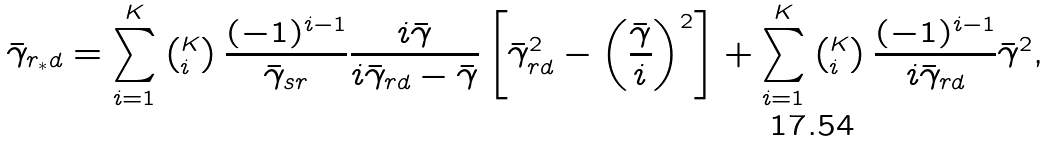<formula> <loc_0><loc_0><loc_500><loc_500>\bar { \gamma } _ { r _ { * } d } = \sum _ { i = 1 } ^ { K } \left ( _ { i } ^ { K } \right ) \frac { ( - 1 ) ^ { i - 1 } } { \bar { \gamma } _ { s r } } \frac { i \bar { \gamma } } { i \bar { \gamma } _ { r d } - \bar { \gamma } } \left [ \bar { \gamma } _ { r d } ^ { 2 } - \left ( \frac { \bar { \gamma } } { i } \right ) ^ { 2 } \right ] + \sum _ { i = 1 } ^ { K } \left ( _ { i } ^ { K } \right ) \frac { ( - 1 ) ^ { i - 1 } } { i \bar { \gamma } _ { r d } } \bar { \gamma } ^ { 2 } ,</formula> 